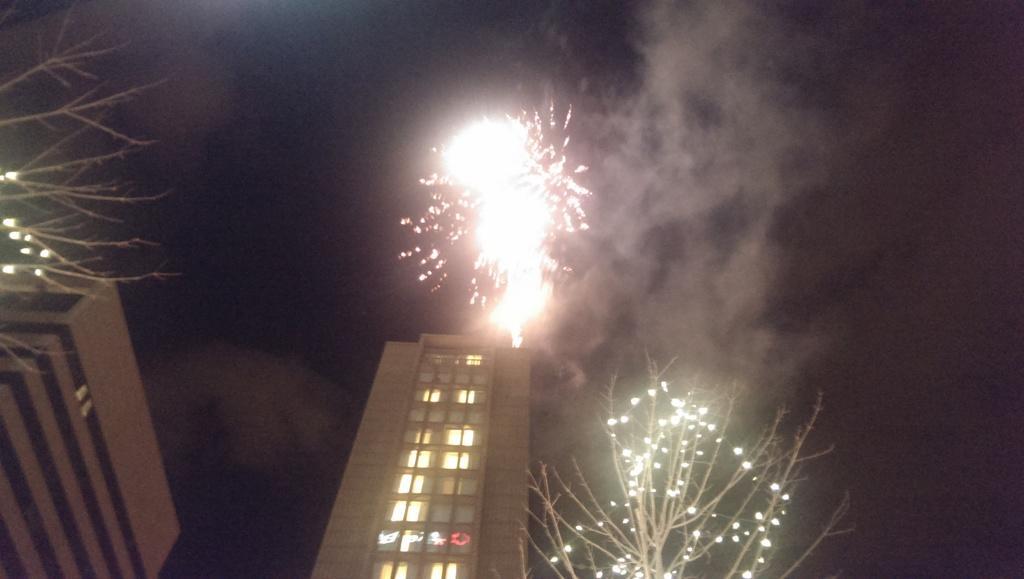In one or two sentences, can you explain what this image depicts? In this image two trees are decorated with some lights on them. There are two buildings behind them. There are fireworks glowing in the sky. 